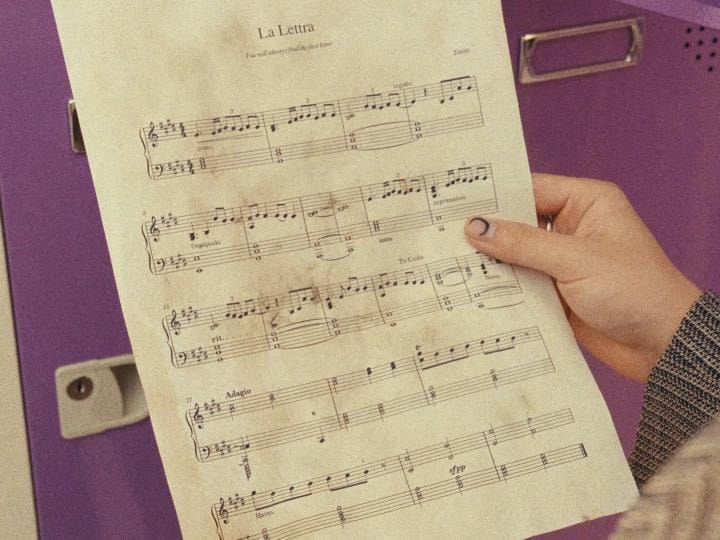List everything weird or unusual in the image. In the image you provided, here are a few unusual elements:

1. **Context of the Background**: The purple background against the sheet music presents an unusual color choice for a setting where one might expect to find sheet music, typically a music room or a personal study area which usually have more neutral colors.

2. **Drawer Handle Orientation**: The handle on the drawer in the background is mounted vertically rather than horizontally, which is less common for drawer handles.

3. **Mismatched Aesthetics**: The worn-out and aged look of the sheet music contrasts with the modern and clean appearance of the drawer and the background, creating a visual mismatch in terms of time periods or styles.

These elements contribute to a slightly quirky or unexpected visual narrative in the image. 